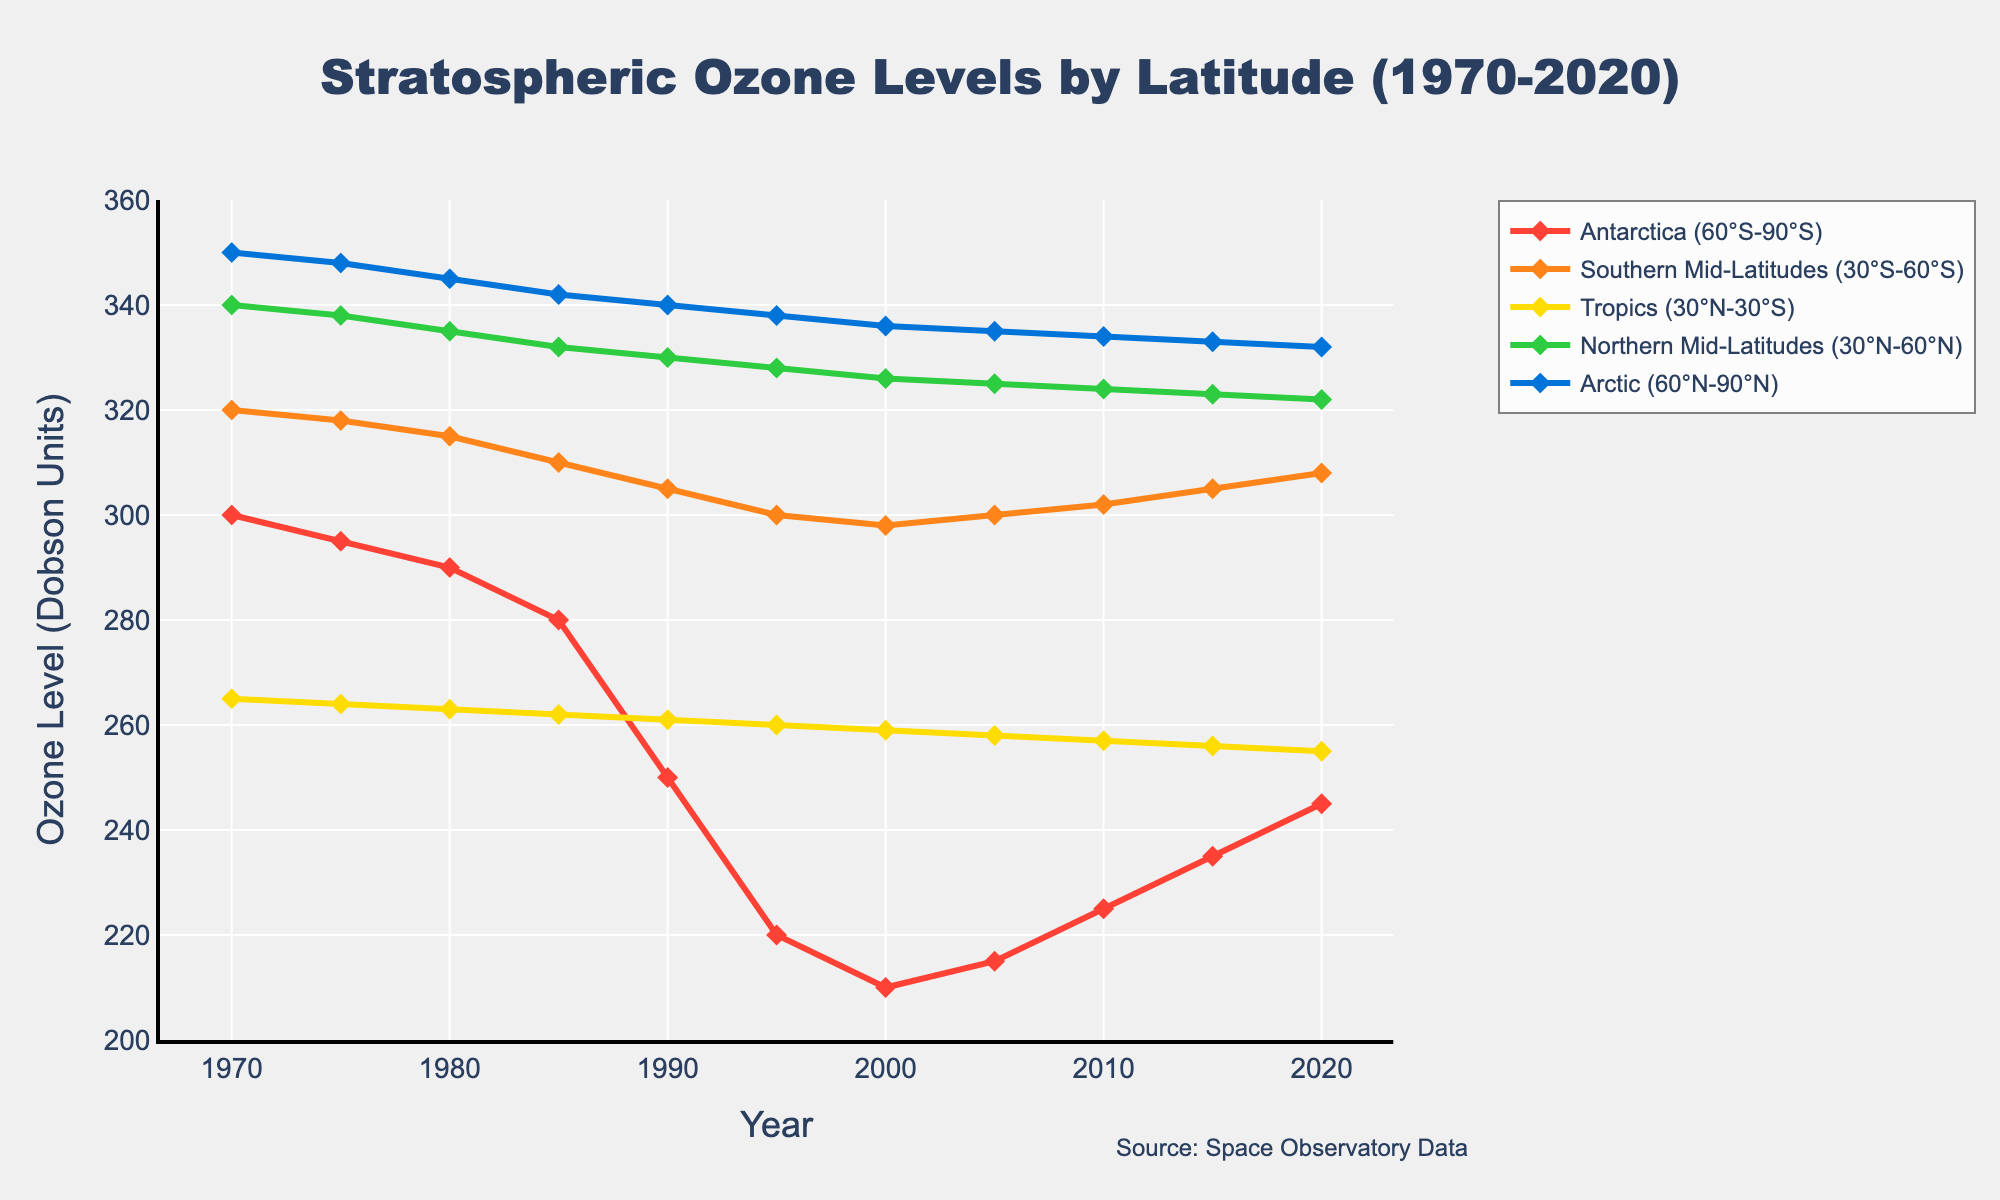What's the trend in stratospheric ozone levels in Antarctica (60°S-90°S) from 1970 to 2020? By examining the line chart, we can see that the ozone levels in Antarctica decreased significantly from 300 Dobson Units in 1970 to around 210 Dobson Units in 2000 and then gradually increased to 245 Dobson Units by 2020. This indicates a decreasing trend followed by a recovery.
Answer: Decrease, then increase Which latitude experienced the lowest ozone level in 2000? Observing the data points for the year 2000 in the line chart, it is evident that Antarctica (60°S-90°S) had the lowest ozone level at 210 Dobson Units.
Answer: Antarctica How do the ozone levels in the Tropics (30°N-30°S) compare to the Southern Mid-Latitudes (30°S-60°S) in 1985? By comparing the two lines for the year 1985 in the chart, the Southern Mid-Latitudes had an ozone level of 310 Dobson Units, while the Tropics had 262 Dobson Units. This shows that the Southern Mid-Latitudes had higher ozone levels.
Answer: Higher in Southern Mid-Latitudes What was the percentage decrease in ozone levels in Antarctica (60°S-90°S) from 1970 to 2000? The ozone level in Antarctica was 300 Dobson Units in 1970 and reduced to 210 Dobson Units in 2000. The percentage decrease is calculated as [(300-210)/300] * 100 = 30%.
Answer: 30% Which region showed the least variability in ozone levels from 1970 to 2020? By looking at the stability of the lines, the Tropics (30°N-30°S) had the least variability in its ozone levels, staying relatively stable around 255-265 Dobson Units throughout the period.
Answer: Tropics How did the ozone levels in the Arctic (60°N-90°N) change from 1990 to 2020? Analyzing the line for the Arctic, ozone levels dropped from around 340 Dobson Units in 1990 to around 332 Dobson Units in 2020, showing a slight decline.
Answer: Slight decline Which latitude had the highest ozone levels in 2010? The highest point in the 2010 segment of the chart corresponds to the Arctic (60°N-90°N), which had an ozone level of 334 Dobson Units.
Answer: Arctic Calculate the average ozone level for the Southern Mid-Latitudes (30°S-60°S) between 1990 and 2020. The ozone levels for the Southern Mid-Latitudes (30°S-60°S) are 305, 300, 298, 300, 302, 305, and 308 for the respective years. Their average is (305+300+298+300+302+305+308)/7 = 302.57 Dobson Units.
Answer: 302.57 By how much did the ozone level in the Northern Mid-Latitudes (30°N-60°N) decrease from 1970 to 1995? The ozone level in 1970 was 340 Dobson Units and in 1995 it was 328 Dobson Units. The decrease is 340 - 328 = 12 Dobson Units.
Answer: 12 Estimate the recovery in ozone levels for Antarctica (60°S-90°S) between 2000 and 2020. From 2000 to 2020, the ozone level in Antarctica increased from 210 to 245 Dobson Units. The recovery is 245 - 210 = 35 Dobson Units.
Answer: 35 